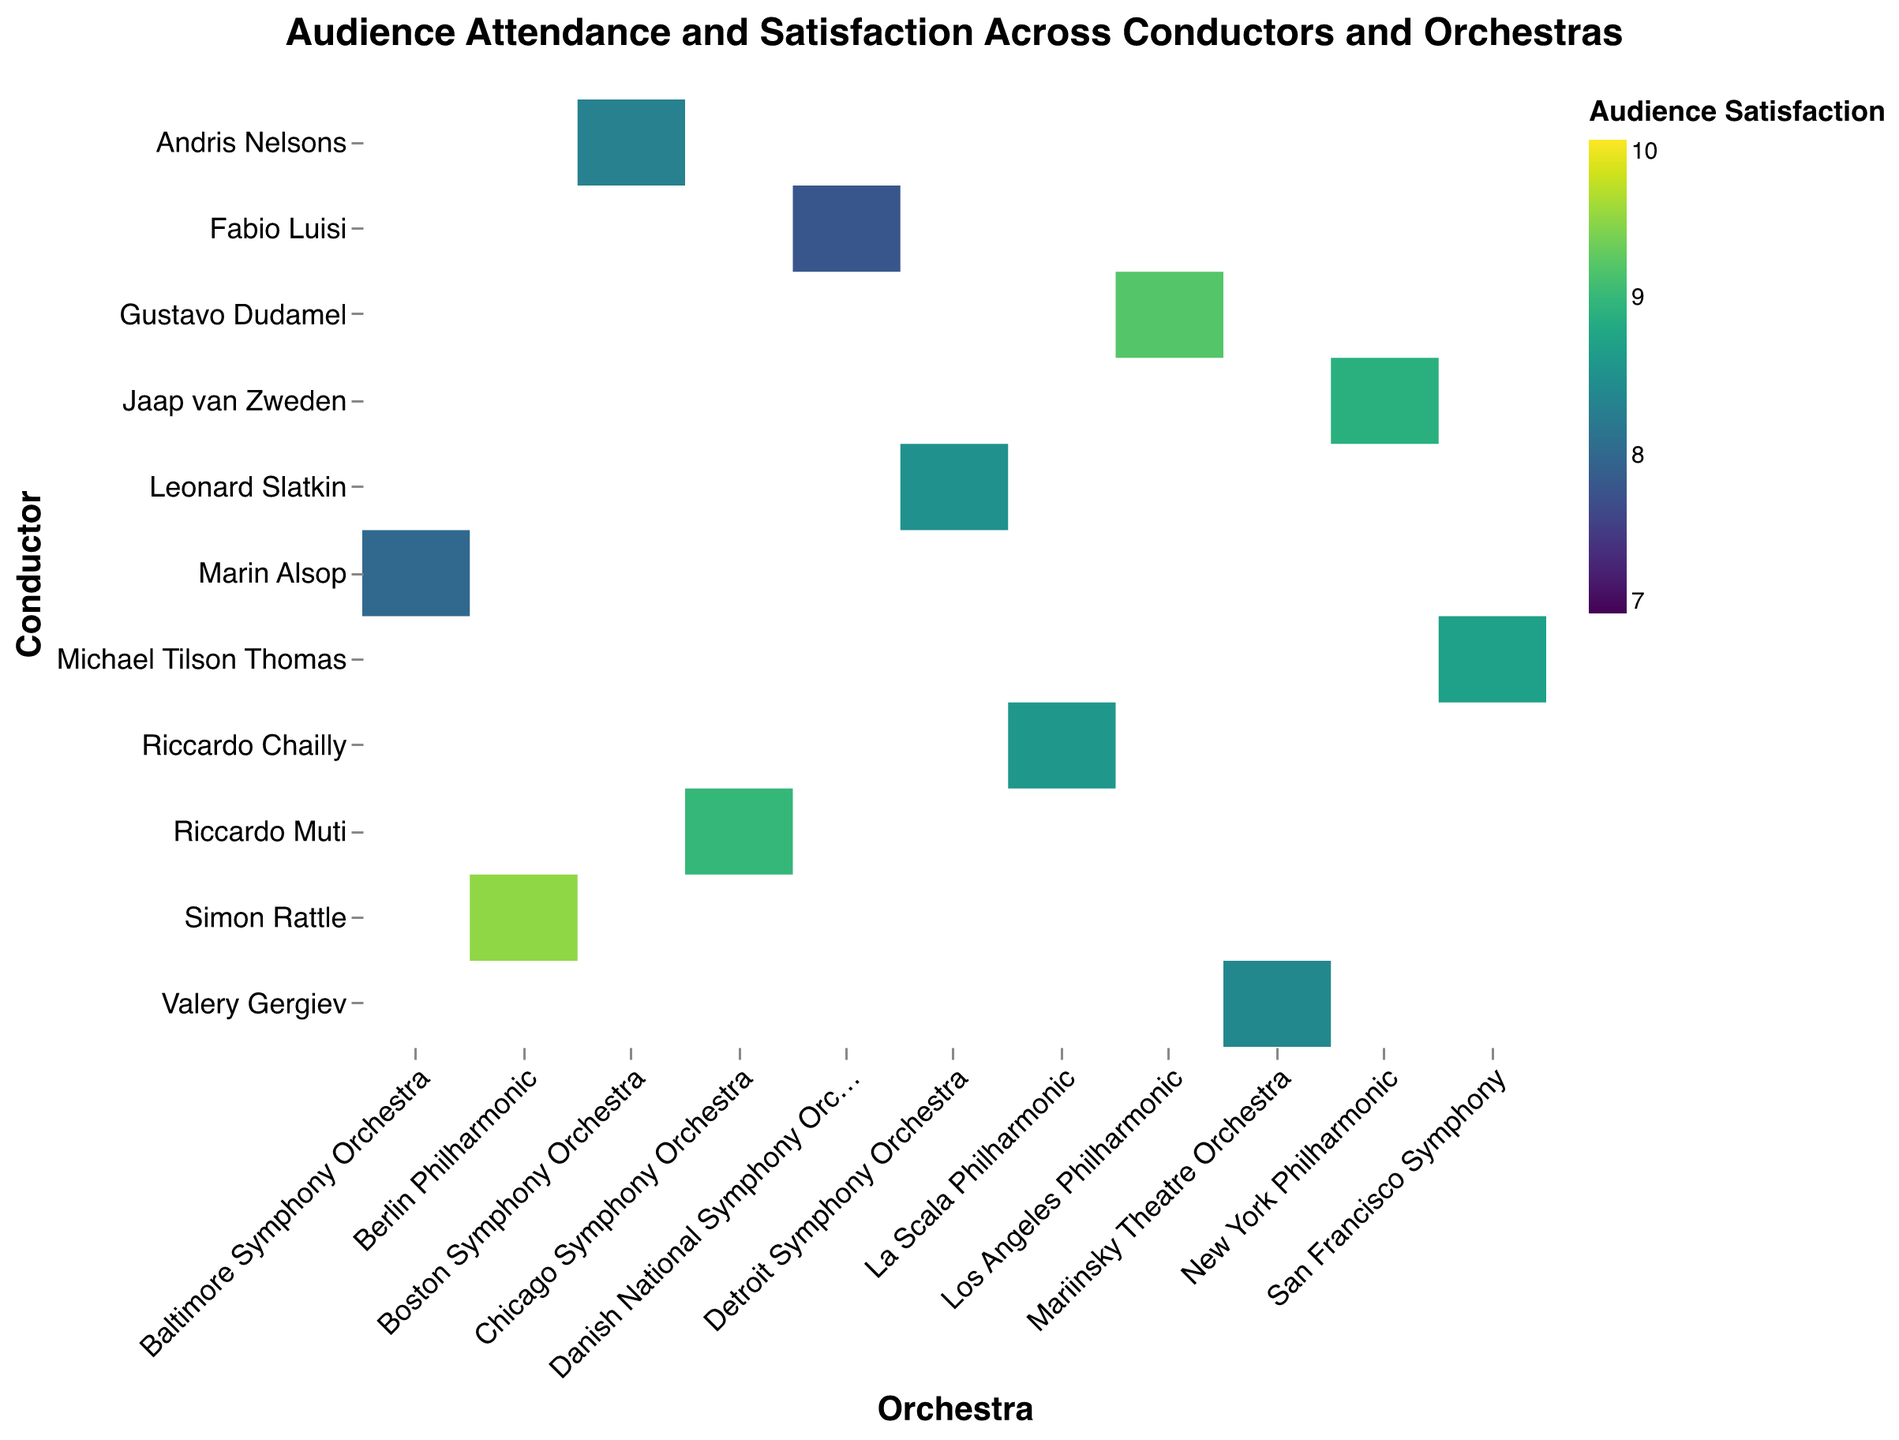How many orchestras are shown in the heatmap? Count the unique orchestras listed along the x-axis. There are 11 orchestras present (Detroit Symphony Orchestra, Los Angeles Philharmonic, Baltimore Symphony Orchestra, Chicago Symphony Orchestra, San Francisco Symphony, Mariinsky Theatre Orchestra, Berlin Philharmonic, La Scala Philharmonic, New York Philharmonic, Boston Symphony Orchestra, and Danish National Symphony Orchestra).
Answer: 11 Which conductor has the highest audience satisfaction rating? Look for the darkest color shade among the conductor cells in the heatmap. Simon Rattle has the highest audience satisfaction of 9.5 with Berlin Philharmonic.
Answer: Simon Rattle Which conductor leads the orchestra with the lowest audience attendance? Identify the smallest rectangle on the heatmap, which represents the lowest audience attendance. The smallest rectangle corresponds to Fabio Luisi with the Danish National Symphony Orchestra, having 1200 attendees.
Answer: Fabio Luisi Which conductor and orchestra combination has both high attendance and high satisfaction? Look for a larger rectangle (high attendance) with a darker color shade (high satisfaction). Simon Rattle with Berlin Philharmonic shows high values in both categories with 2300 attendees and a satisfaction rating of 9.5.
Answer: Simon Rattle and Berlin Philharmonic How does the satisfaction level of Marin Alsop with Baltimore Symphony Orchestra compare to Valery Gergiev with Mariinsky Theatre Orchestra? Find the satisfaction scores for both Marin Alsop (8.0) and Valery Gergiev (8.4) on the heatmap and compare them. Marin Alsop has a lower satisfaction score compared to Valery Gergiev.
Answer: Marin Alsop has a lower satisfaction What's the average audience attendance across all conductors? Sum the attendance numbers of all the conductors from the heatmap (1500 + 2000 + 1400 + 2200 + 1900 + 2100 + 2300 + 1800 + 1700 + 1600 + 1200), which equals 20700. Then, divide by the number of conductors, which is 11, giving an average audience attendance of 20700/11 = 1881.
Answer: 1881 Which conductor has the biggest discrepancy between audience satisfaction and attendance? Compare satisfaction and attendance for each conductor by observing the size and color of the rectangles. Fabio Luisi has a low audience attendance (1200) and the lowest satisfaction (7.8), highlighting a significant discrepancy.
Answer: Fabio Luisi What is the total audience attendance for orchestras with a satisfaction rating above 9? Sum the audience attendance numbers for the orchestras with a satisfaction rating above 9. Gustav Dudamel (2000 attendees), Riccardo Muti (2200 attendees), and Simon Rattle (2300 attendees) have satisfaction ratings above 9, leading to a total of 2000 + 2200 + 2300 = 6500 attendees.
Answer: 6500 